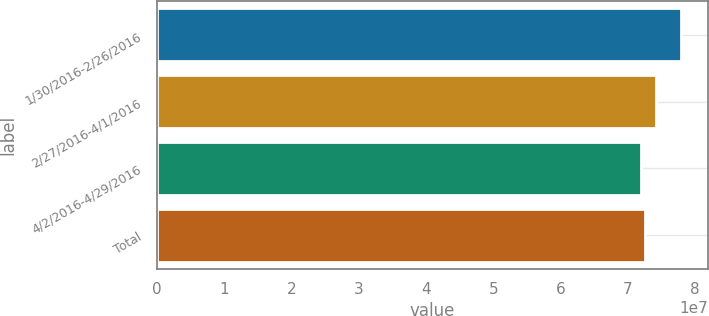Convert chart. <chart><loc_0><loc_0><loc_500><loc_500><bar_chart><fcel>1/30/2016-2/26/2016<fcel>2/27/2016-4/1/2016<fcel>4/2/2016-4/29/2016<fcel>Total<nl><fcel>7.79399e+07<fcel>7.42297e+07<fcel>7.18787e+07<fcel>7.24849e+07<nl></chart> 